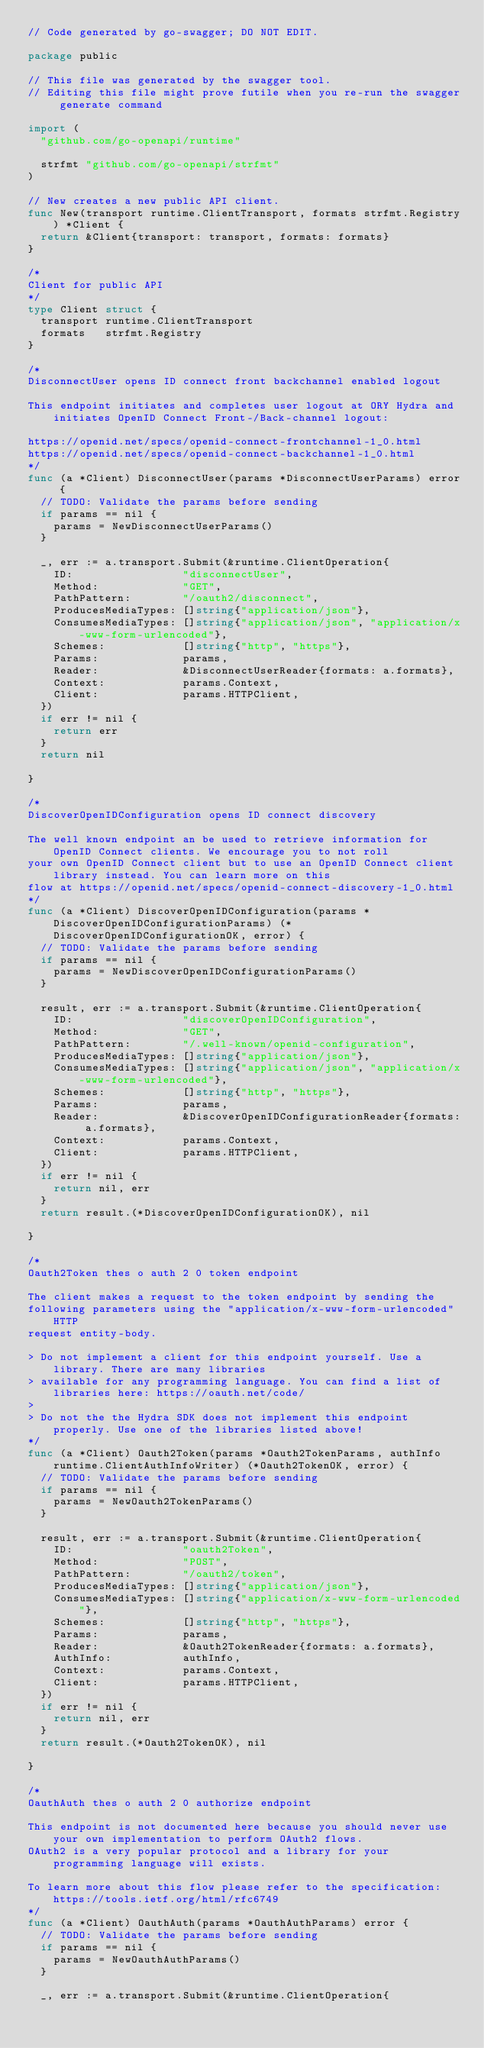Convert code to text. <code><loc_0><loc_0><loc_500><loc_500><_Go_>// Code generated by go-swagger; DO NOT EDIT.

package public

// This file was generated by the swagger tool.
// Editing this file might prove futile when you re-run the swagger generate command

import (
	"github.com/go-openapi/runtime"

	strfmt "github.com/go-openapi/strfmt"
)

// New creates a new public API client.
func New(transport runtime.ClientTransport, formats strfmt.Registry) *Client {
	return &Client{transport: transport, formats: formats}
}

/*
Client for public API
*/
type Client struct {
	transport runtime.ClientTransport
	formats   strfmt.Registry
}

/*
DisconnectUser opens ID connect front backchannel enabled logout

This endpoint initiates and completes user logout at ORY Hydra and initiates OpenID Connect Front-/Back-channel logout:

https://openid.net/specs/openid-connect-frontchannel-1_0.html
https://openid.net/specs/openid-connect-backchannel-1_0.html
*/
func (a *Client) DisconnectUser(params *DisconnectUserParams) error {
	// TODO: Validate the params before sending
	if params == nil {
		params = NewDisconnectUserParams()
	}

	_, err := a.transport.Submit(&runtime.ClientOperation{
		ID:                 "disconnectUser",
		Method:             "GET",
		PathPattern:        "/oauth2/disconnect",
		ProducesMediaTypes: []string{"application/json"},
		ConsumesMediaTypes: []string{"application/json", "application/x-www-form-urlencoded"},
		Schemes:            []string{"http", "https"},
		Params:             params,
		Reader:             &DisconnectUserReader{formats: a.formats},
		Context:            params.Context,
		Client:             params.HTTPClient,
	})
	if err != nil {
		return err
	}
	return nil

}

/*
DiscoverOpenIDConfiguration opens ID connect discovery

The well known endpoint an be used to retrieve information for OpenID Connect clients. We encourage you to not roll
your own OpenID Connect client but to use an OpenID Connect client library instead. You can learn more on this
flow at https://openid.net/specs/openid-connect-discovery-1_0.html
*/
func (a *Client) DiscoverOpenIDConfiguration(params *DiscoverOpenIDConfigurationParams) (*DiscoverOpenIDConfigurationOK, error) {
	// TODO: Validate the params before sending
	if params == nil {
		params = NewDiscoverOpenIDConfigurationParams()
	}

	result, err := a.transport.Submit(&runtime.ClientOperation{
		ID:                 "discoverOpenIDConfiguration",
		Method:             "GET",
		PathPattern:        "/.well-known/openid-configuration",
		ProducesMediaTypes: []string{"application/json"},
		ConsumesMediaTypes: []string{"application/json", "application/x-www-form-urlencoded"},
		Schemes:            []string{"http", "https"},
		Params:             params,
		Reader:             &DiscoverOpenIDConfigurationReader{formats: a.formats},
		Context:            params.Context,
		Client:             params.HTTPClient,
	})
	if err != nil {
		return nil, err
	}
	return result.(*DiscoverOpenIDConfigurationOK), nil

}

/*
Oauth2Token thes o auth 2 0 token endpoint

The client makes a request to the token endpoint by sending the
following parameters using the "application/x-www-form-urlencoded" HTTP
request entity-body.

> Do not implement a client for this endpoint yourself. Use a library. There are many libraries
> available for any programming language. You can find a list of libraries here: https://oauth.net/code/
>
> Do not the the Hydra SDK does not implement this endpoint properly. Use one of the libraries listed above!
*/
func (a *Client) Oauth2Token(params *Oauth2TokenParams, authInfo runtime.ClientAuthInfoWriter) (*Oauth2TokenOK, error) {
	// TODO: Validate the params before sending
	if params == nil {
		params = NewOauth2TokenParams()
	}

	result, err := a.transport.Submit(&runtime.ClientOperation{
		ID:                 "oauth2Token",
		Method:             "POST",
		PathPattern:        "/oauth2/token",
		ProducesMediaTypes: []string{"application/json"},
		ConsumesMediaTypes: []string{"application/x-www-form-urlencoded"},
		Schemes:            []string{"http", "https"},
		Params:             params,
		Reader:             &Oauth2TokenReader{formats: a.formats},
		AuthInfo:           authInfo,
		Context:            params.Context,
		Client:             params.HTTPClient,
	})
	if err != nil {
		return nil, err
	}
	return result.(*Oauth2TokenOK), nil

}

/*
OauthAuth thes o auth 2 0 authorize endpoint

This endpoint is not documented here because you should never use your own implementation to perform OAuth2 flows.
OAuth2 is a very popular protocol and a library for your programming language will exists.

To learn more about this flow please refer to the specification: https://tools.ietf.org/html/rfc6749
*/
func (a *Client) OauthAuth(params *OauthAuthParams) error {
	// TODO: Validate the params before sending
	if params == nil {
		params = NewOauthAuthParams()
	}

	_, err := a.transport.Submit(&runtime.ClientOperation{</code> 